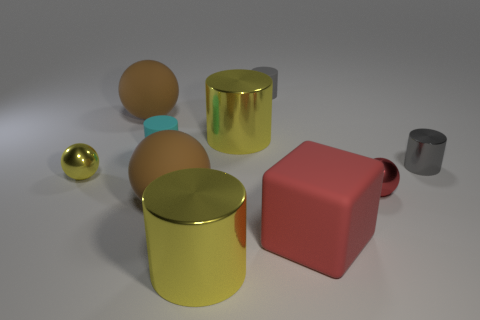What size is the ball that is the same color as the rubber cube?
Your answer should be very brief. Small. There is a brown ball in front of the small red metal thing; what is it made of?
Give a very brief answer. Rubber. Is the number of large red cubes that are behind the tiny shiny cylinder the same as the number of big brown objects that are left of the cyan cylinder?
Offer a very short reply. No. There is a yellow cylinder in front of the rubber cube; is it the same size as the yellow thing that is behind the tiny cyan rubber thing?
Give a very brief answer. Yes. How many spheres have the same color as the block?
Provide a succinct answer. 1. There is a tiny object that is the same color as the big matte block; what is its material?
Offer a terse response. Metal. Is the number of brown things that are to the right of the tiny cyan object greater than the number of red things?
Keep it short and to the point. No. Is the shape of the tiny red metallic object the same as the gray matte thing?
Ensure brevity in your answer.  No. How many red things have the same material as the small yellow ball?
Your answer should be very brief. 1. The yellow shiny thing that is the same shape as the tiny red metal thing is what size?
Provide a succinct answer. Small. 